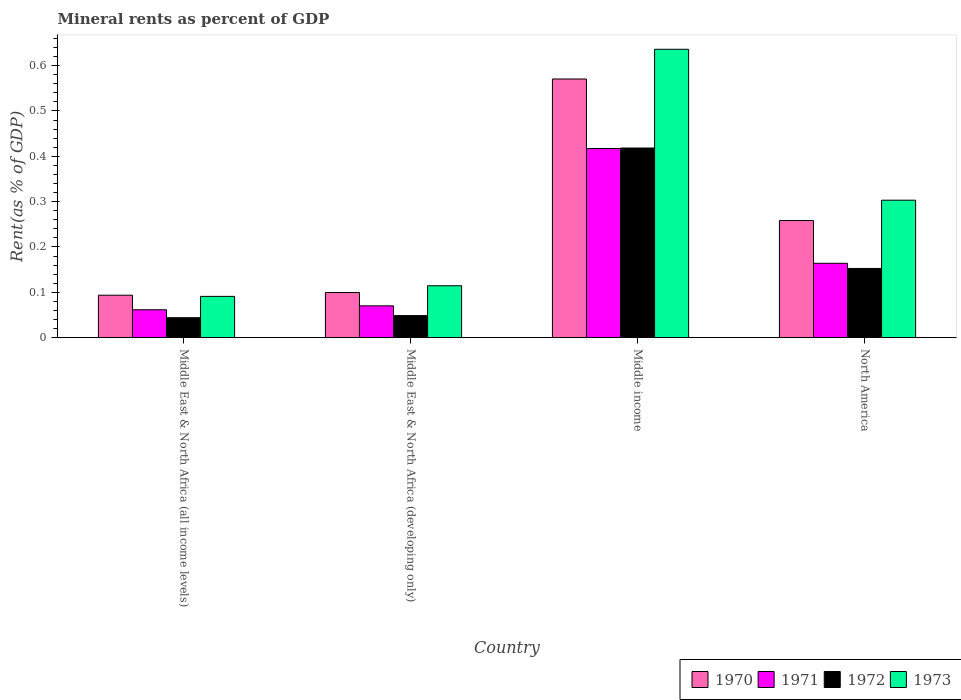How many different coloured bars are there?
Give a very brief answer. 4. Are the number of bars per tick equal to the number of legend labels?
Provide a succinct answer. Yes. Are the number of bars on each tick of the X-axis equal?
Provide a short and direct response. Yes. How many bars are there on the 4th tick from the right?
Keep it short and to the point. 4. What is the mineral rent in 1971 in Middle income?
Provide a short and direct response. 0.42. Across all countries, what is the maximum mineral rent in 1973?
Your answer should be very brief. 0.64. Across all countries, what is the minimum mineral rent in 1970?
Make the answer very short. 0.09. In which country was the mineral rent in 1971 minimum?
Offer a terse response. Middle East & North Africa (all income levels). What is the total mineral rent in 1971 in the graph?
Provide a short and direct response. 0.71. What is the difference between the mineral rent in 1970 in Middle East & North Africa (all income levels) and that in Middle income?
Your response must be concise. -0.48. What is the difference between the mineral rent in 1973 in Middle East & North Africa (all income levels) and the mineral rent in 1972 in Middle income?
Your answer should be very brief. -0.33. What is the average mineral rent in 1972 per country?
Give a very brief answer. 0.17. What is the difference between the mineral rent of/in 1973 and mineral rent of/in 1971 in Middle income?
Make the answer very short. 0.22. In how many countries, is the mineral rent in 1971 greater than 0.04 %?
Offer a terse response. 4. What is the ratio of the mineral rent in 1973 in Middle income to that in North America?
Make the answer very short. 2.1. Is the mineral rent in 1972 in Middle East & North Africa (developing only) less than that in North America?
Keep it short and to the point. Yes. What is the difference between the highest and the second highest mineral rent in 1971?
Provide a succinct answer. 0.25. What is the difference between the highest and the lowest mineral rent in 1971?
Give a very brief answer. 0.36. Is the sum of the mineral rent in 1973 in Middle East & North Africa (developing only) and Middle income greater than the maximum mineral rent in 1972 across all countries?
Provide a short and direct response. Yes. What does the 2nd bar from the left in Middle income represents?
Make the answer very short. 1971. What does the 3rd bar from the right in Middle income represents?
Offer a very short reply. 1971. Is it the case that in every country, the sum of the mineral rent in 1973 and mineral rent in 1972 is greater than the mineral rent in 1971?
Offer a terse response. Yes. Are all the bars in the graph horizontal?
Make the answer very short. No. What is the difference between two consecutive major ticks on the Y-axis?
Make the answer very short. 0.1. Are the values on the major ticks of Y-axis written in scientific E-notation?
Provide a succinct answer. No. Does the graph contain any zero values?
Offer a very short reply. No. How are the legend labels stacked?
Your response must be concise. Horizontal. What is the title of the graph?
Your response must be concise. Mineral rents as percent of GDP. What is the label or title of the Y-axis?
Your answer should be very brief. Rent(as % of GDP). What is the Rent(as % of GDP) in 1970 in Middle East & North Africa (all income levels)?
Your answer should be very brief. 0.09. What is the Rent(as % of GDP) in 1971 in Middle East & North Africa (all income levels)?
Give a very brief answer. 0.06. What is the Rent(as % of GDP) of 1972 in Middle East & North Africa (all income levels)?
Your answer should be compact. 0.04. What is the Rent(as % of GDP) of 1973 in Middle East & North Africa (all income levels)?
Offer a terse response. 0.09. What is the Rent(as % of GDP) of 1970 in Middle East & North Africa (developing only)?
Offer a terse response. 0.1. What is the Rent(as % of GDP) in 1971 in Middle East & North Africa (developing only)?
Offer a very short reply. 0.07. What is the Rent(as % of GDP) in 1972 in Middle East & North Africa (developing only)?
Ensure brevity in your answer.  0.05. What is the Rent(as % of GDP) of 1973 in Middle East & North Africa (developing only)?
Offer a terse response. 0.11. What is the Rent(as % of GDP) in 1970 in Middle income?
Make the answer very short. 0.57. What is the Rent(as % of GDP) in 1971 in Middle income?
Make the answer very short. 0.42. What is the Rent(as % of GDP) of 1972 in Middle income?
Keep it short and to the point. 0.42. What is the Rent(as % of GDP) in 1973 in Middle income?
Offer a very short reply. 0.64. What is the Rent(as % of GDP) in 1970 in North America?
Make the answer very short. 0.26. What is the Rent(as % of GDP) in 1971 in North America?
Provide a short and direct response. 0.16. What is the Rent(as % of GDP) in 1972 in North America?
Ensure brevity in your answer.  0.15. What is the Rent(as % of GDP) in 1973 in North America?
Your response must be concise. 0.3. Across all countries, what is the maximum Rent(as % of GDP) in 1970?
Give a very brief answer. 0.57. Across all countries, what is the maximum Rent(as % of GDP) of 1971?
Keep it short and to the point. 0.42. Across all countries, what is the maximum Rent(as % of GDP) in 1972?
Offer a terse response. 0.42. Across all countries, what is the maximum Rent(as % of GDP) of 1973?
Make the answer very short. 0.64. Across all countries, what is the minimum Rent(as % of GDP) in 1970?
Provide a succinct answer. 0.09. Across all countries, what is the minimum Rent(as % of GDP) in 1971?
Make the answer very short. 0.06. Across all countries, what is the minimum Rent(as % of GDP) in 1972?
Offer a very short reply. 0.04. Across all countries, what is the minimum Rent(as % of GDP) in 1973?
Offer a very short reply. 0.09. What is the total Rent(as % of GDP) in 1970 in the graph?
Provide a short and direct response. 1.02. What is the total Rent(as % of GDP) of 1971 in the graph?
Provide a succinct answer. 0.71. What is the total Rent(as % of GDP) in 1972 in the graph?
Offer a very short reply. 0.66. What is the total Rent(as % of GDP) of 1973 in the graph?
Keep it short and to the point. 1.14. What is the difference between the Rent(as % of GDP) of 1970 in Middle East & North Africa (all income levels) and that in Middle East & North Africa (developing only)?
Make the answer very short. -0.01. What is the difference between the Rent(as % of GDP) of 1971 in Middle East & North Africa (all income levels) and that in Middle East & North Africa (developing only)?
Ensure brevity in your answer.  -0.01. What is the difference between the Rent(as % of GDP) in 1972 in Middle East & North Africa (all income levels) and that in Middle East & North Africa (developing only)?
Provide a short and direct response. -0. What is the difference between the Rent(as % of GDP) in 1973 in Middle East & North Africa (all income levels) and that in Middle East & North Africa (developing only)?
Your answer should be very brief. -0.02. What is the difference between the Rent(as % of GDP) of 1970 in Middle East & North Africa (all income levels) and that in Middle income?
Give a very brief answer. -0.48. What is the difference between the Rent(as % of GDP) of 1971 in Middle East & North Africa (all income levels) and that in Middle income?
Your answer should be compact. -0.36. What is the difference between the Rent(as % of GDP) of 1972 in Middle East & North Africa (all income levels) and that in Middle income?
Give a very brief answer. -0.37. What is the difference between the Rent(as % of GDP) in 1973 in Middle East & North Africa (all income levels) and that in Middle income?
Offer a very short reply. -0.55. What is the difference between the Rent(as % of GDP) in 1970 in Middle East & North Africa (all income levels) and that in North America?
Ensure brevity in your answer.  -0.16. What is the difference between the Rent(as % of GDP) in 1971 in Middle East & North Africa (all income levels) and that in North America?
Provide a short and direct response. -0.1. What is the difference between the Rent(as % of GDP) of 1972 in Middle East & North Africa (all income levels) and that in North America?
Your answer should be very brief. -0.11. What is the difference between the Rent(as % of GDP) of 1973 in Middle East & North Africa (all income levels) and that in North America?
Ensure brevity in your answer.  -0.21. What is the difference between the Rent(as % of GDP) of 1970 in Middle East & North Africa (developing only) and that in Middle income?
Provide a short and direct response. -0.47. What is the difference between the Rent(as % of GDP) of 1971 in Middle East & North Africa (developing only) and that in Middle income?
Ensure brevity in your answer.  -0.35. What is the difference between the Rent(as % of GDP) of 1972 in Middle East & North Africa (developing only) and that in Middle income?
Give a very brief answer. -0.37. What is the difference between the Rent(as % of GDP) in 1973 in Middle East & North Africa (developing only) and that in Middle income?
Provide a short and direct response. -0.52. What is the difference between the Rent(as % of GDP) in 1970 in Middle East & North Africa (developing only) and that in North America?
Make the answer very short. -0.16. What is the difference between the Rent(as % of GDP) of 1971 in Middle East & North Africa (developing only) and that in North America?
Offer a very short reply. -0.09. What is the difference between the Rent(as % of GDP) of 1972 in Middle East & North Africa (developing only) and that in North America?
Your answer should be compact. -0.1. What is the difference between the Rent(as % of GDP) of 1973 in Middle East & North Africa (developing only) and that in North America?
Offer a very short reply. -0.19. What is the difference between the Rent(as % of GDP) in 1970 in Middle income and that in North America?
Make the answer very short. 0.31. What is the difference between the Rent(as % of GDP) in 1971 in Middle income and that in North America?
Your response must be concise. 0.25. What is the difference between the Rent(as % of GDP) of 1972 in Middle income and that in North America?
Your response must be concise. 0.27. What is the difference between the Rent(as % of GDP) in 1973 in Middle income and that in North America?
Offer a terse response. 0.33. What is the difference between the Rent(as % of GDP) of 1970 in Middle East & North Africa (all income levels) and the Rent(as % of GDP) of 1971 in Middle East & North Africa (developing only)?
Ensure brevity in your answer.  0.02. What is the difference between the Rent(as % of GDP) of 1970 in Middle East & North Africa (all income levels) and the Rent(as % of GDP) of 1972 in Middle East & North Africa (developing only)?
Give a very brief answer. 0.04. What is the difference between the Rent(as % of GDP) in 1970 in Middle East & North Africa (all income levels) and the Rent(as % of GDP) in 1973 in Middle East & North Africa (developing only)?
Your answer should be very brief. -0.02. What is the difference between the Rent(as % of GDP) of 1971 in Middle East & North Africa (all income levels) and the Rent(as % of GDP) of 1972 in Middle East & North Africa (developing only)?
Ensure brevity in your answer.  0.01. What is the difference between the Rent(as % of GDP) of 1971 in Middle East & North Africa (all income levels) and the Rent(as % of GDP) of 1973 in Middle East & North Africa (developing only)?
Ensure brevity in your answer.  -0.05. What is the difference between the Rent(as % of GDP) in 1972 in Middle East & North Africa (all income levels) and the Rent(as % of GDP) in 1973 in Middle East & North Africa (developing only)?
Give a very brief answer. -0.07. What is the difference between the Rent(as % of GDP) in 1970 in Middle East & North Africa (all income levels) and the Rent(as % of GDP) in 1971 in Middle income?
Your answer should be compact. -0.32. What is the difference between the Rent(as % of GDP) of 1970 in Middle East & North Africa (all income levels) and the Rent(as % of GDP) of 1972 in Middle income?
Offer a terse response. -0.32. What is the difference between the Rent(as % of GDP) of 1970 in Middle East & North Africa (all income levels) and the Rent(as % of GDP) of 1973 in Middle income?
Ensure brevity in your answer.  -0.54. What is the difference between the Rent(as % of GDP) in 1971 in Middle East & North Africa (all income levels) and the Rent(as % of GDP) in 1972 in Middle income?
Provide a short and direct response. -0.36. What is the difference between the Rent(as % of GDP) of 1971 in Middle East & North Africa (all income levels) and the Rent(as % of GDP) of 1973 in Middle income?
Provide a short and direct response. -0.57. What is the difference between the Rent(as % of GDP) of 1972 in Middle East & North Africa (all income levels) and the Rent(as % of GDP) of 1973 in Middle income?
Make the answer very short. -0.59. What is the difference between the Rent(as % of GDP) in 1970 in Middle East & North Africa (all income levels) and the Rent(as % of GDP) in 1971 in North America?
Your response must be concise. -0.07. What is the difference between the Rent(as % of GDP) of 1970 in Middle East & North Africa (all income levels) and the Rent(as % of GDP) of 1972 in North America?
Your response must be concise. -0.06. What is the difference between the Rent(as % of GDP) of 1970 in Middle East & North Africa (all income levels) and the Rent(as % of GDP) of 1973 in North America?
Ensure brevity in your answer.  -0.21. What is the difference between the Rent(as % of GDP) in 1971 in Middle East & North Africa (all income levels) and the Rent(as % of GDP) in 1972 in North America?
Give a very brief answer. -0.09. What is the difference between the Rent(as % of GDP) in 1971 in Middle East & North Africa (all income levels) and the Rent(as % of GDP) in 1973 in North America?
Give a very brief answer. -0.24. What is the difference between the Rent(as % of GDP) of 1972 in Middle East & North Africa (all income levels) and the Rent(as % of GDP) of 1973 in North America?
Your answer should be very brief. -0.26. What is the difference between the Rent(as % of GDP) of 1970 in Middle East & North Africa (developing only) and the Rent(as % of GDP) of 1971 in Middle income?
Your answer should be very brief. -0.32. What is the difference between the Rent(as % of GDP) in 1970 in Middle East & North Africa (developing only) and the Rent(as % of GDP) in 1972 in Middle income?
Give a very brief answer. -0.32. What is the difference between the Rent(as % of GDP) of 1970 in Middle East & North Africa (developing only) and the Rent(as % of GDP) of 1973 in Middle income?
Your answer should be compact. -0.54. What is the difference between the Rent(as % of GDP) of 1971 in Middle East & North Africa (developing only) and the Rent(as % of GDP) of 1972 in Middle income?
Give a very brief answer. -0.35. What is the difference between the Rent(as % of GDP) in 1971 in Middle East & North Africa (developing only) and the Rent(as % of GDP) in 1973 in Middle income?
Offer a terse response. -0.57. What is the difference between the Rent(as % of GDP) in 1972 in Middle East & North Africa (developing only) and the Rent(as % of GDP) in 1973 in Middle income?
Offer a very short reply. -0.59. What is the difference between the Rent(as % of GDP) in 1970 in Middle East & North Africa (developing only) and the Rent(as % of GDP) in 1971 in North America?
Provide a succinct answer. -0.06. What is the difference between the Rent(as % of GDP) in 1970 in Middle East & North Africa (developing only) and the Rent(as % of GDP) in 1972 in North America?
Provide a short and direct response. -0.05. What is the difference between the Rent(as % of GDP) in 1970 in Middle East & North Africa (developing only) and the Rent(as % of GDP) in 1973 in North America?
Keep it short and to the point. -0.2. What is the difference between the Rent(as % of GDP) of 1971 in Middle East & North Africa (developing only) and the Rent(as % of GDP) of 1972 in North America?
Your answer should be compact. -0.08. What is the difference between the Rent(as % of GDP) in 1971 in Middle East & North Africa (developing only) and the Rent(as % of GDP) in 1973 in North America?
Provide a succinct answer. -0.23. What is the difference between the Rent(as % of GDP) of 1972 in Middle East & North Africa (developing only) and the Rent(as % of GDP) of 1973 in North America?
Provide a short and direct response. -0.25. What is the difference between the Rent(as % of GDP) in 1970 in Middle income and the Rent(as % of GDP) in 1971 in North America?
Provide a succinct answer. 0.41. What is the difference between the Rent(as % of GDP) of 1970 in Middle income and the Rent(as % of GDP) of 1972 in North America?
Make the answer very short. 0.42. What is the difference between the Rent(as % of GDP) of 1970 in Middle income and the Rent(as % of GDP) of 1973 in North America?
Your response must be concise. 0.27. What is the difference between the Rent(as % of GDP) of 1971 in Middle income and the Rent(as % of GDP) of 1972 in North America?
Offer a very short reply. 0.26. What is the difference between the Rent(as % of GDP) of 1971 in Middle income and the Rent(as % of GDP) of 1973 in North America?
Ensure brevity in your answer.  0.11. What is the difference between the Rent(as % of GDP) in 1972 in Middle income and the Rent(as % of GDP) in 1973 in North America?
Offer a terse response. 0.12. What is the average Rent(as % of GDP) in 1970 per country?
Your answer should be compact. 0.26. What is the average Rent(as % of GDP) in 1971 per country?
Make the answer very short. 0.18. What is the average Rent(as % of GDP) in 1972 per country?
Keep it short and to the point. 0.17. What is the average Rent(as % of GDP) of 1973 per country?
Offer a terse response. 0.29. What is the difference between the Rent(as % of GDP) of 1970 and Rent(as % of GDP) of 1971 in Middle East & North Africa (all income levels)?
Provide a succinct answer. 0.03. What is the difference between the Rent(as % of GDP) in 1970 and Rent(as % of GDP) in 1972 in Middle East & North Africa (all income levels)?
Offer a terse response. 0.05. What is the difference between the Rent(as % of GDP) in 1970 and Rent(as % of GDP) in 1973 in Middle East & North Africa (all income levels)?
Provide a succinct answer. 0. What is the difference between the Rent(as % of GDP) in 1971 and Rent(as % of GDP) in 1972 in Middle East & North Africa (all income levels)?
Your response must be concise. 0.02. What is the difference between the Rent(as % of GDP) of 1971 and Rent(as % of GDP) of 1973 in Middle East & North Africa (all income levels)?
Provide a short and direct response. -0.03. What is the difference between the Rent(as % of GDP) of 1972 and Rent(as % of GDP) of 1973 in Middle East & North Africa (all income levels)?
Make the answer very short. -0.05. What is the difference between the Rent(as % of GDP) in 1970 and Rent(as % of GDP) in 1971 in Middle East & North Africa (developing only)?
Give a very brief answer. 0.03. What is the difference between the Rent(as % of GDP) of 1970 and Rent(as % of GDP) of 1972 in Middle East & North Africa (developing only)?
Keep it short and to the point. 0.05. What is the difference between the Rent(as % of GDP) in 1970 and Rent(as % of GDP) in 1973 in Middle East & North Africa (developing only)?
Ensure brevity in your answer.  -0.01. What is the difference between the Rent(as % of GDP) of 1971 and Rent(as % of GDP) of 1972 in Middle East & North Africa (developing only)?
Offer a very short reply. 0.02. What is the difference between the Rent(as % of GDP) in 1971 and Rent(as % of GDP) in 1973 in Middle East & North Africa (developing only)?
Offer a very short reply. -0.04. What is the difference between the Rent(as % of GDP) of 1972 and Rent(as % of GDP) of 1973 in Middle East & North Africa (developing only)?
Provide a short and direct response. -0.07. What is the difference between the Rent(as % of GDP) of 1970 and Rent(as % of GDP) of 1971 in Middle income?
Give a very brief answer. 0.15. What is the difference between the Rent(as % of GDP) in 1970 and Rent(as % of GDP) in 1972 in Middle income?
Keep it short and to the point. 0.15. What is the difference between the Rent(as % of GDP) in 1970 and Rent(as % of GDP) in 1973 in Middle income?
Provide a succinct answer. -0.07. What is the difference between the Rent(as % of GDP) in 1971 and Rent(as % of GDP) in 1972 in Middle income?
Offer a very short reply. -0. What is the difference between the Rent(as % of GDP) in 1971 and Rent(as % of GDP) in 1973 in Middle income?
Ensure brevity in your answer.  -0.22. What is the difference between the Rent(as % of GDP) in 1972 and Rent(as % of GDP) in 1973 in Middle income?
Your answer should be compact. -0.22. What is the difference between the Rent(as % of GDP) in 1970 and Rent(as % of GDP) in 1971 in North America?
Give a very brief answer. 0.09. What is the difference between the Rent(as % of GDP) in 1970 and Rent(as % of GDP) in 1972 in North America?
Make the answer very short. 0.11. What is the difference between the Rent(as % of GDP) in 1970 and Rent(as % of GDP) in 1973 in North America?
Keep it short and to the point. -0.04. What is the difference between the Rent(as % of GDP) of 1971 and Rent(as % of GDP) of 1972 in North America?
Make the answer very short. 0.01. What is the difference between the Rent(as % of GDP) of 1971 and Rent(as % of GDP) of 1973 in North America?
Provide a succinct answer. -0.14. What is the difference between the Rent(as % of GDP) in 1972 and Rent(as % of GDP) in 1973 in North America?
Keep it short and to the point. -0.15. What is the ratio of the Rent(as % of GDP) of 1970 in Middle East & North Africa (all income levels) to that in Middle East & North Africa (developing only)?
Keep it short and to the point. 0.94. What is the ratio of the Rent(as % of GDP) in 1971 in Middle East & North Africa (all income levels) to that in Middle East & North Africa (developing only)?
Ensure brevity in your answer.  0.88. What is the ratio of the Rent(as % of GDP) in 1972 in Middle East & North Africa (all income levels) to that in Middle East & North Africa (developing only)?
Make the answer very short. 0.9. What is the ratio of the Rent(as % of GDP) in 1973 in Middle East & North Africa (all income levels) to that in Middle East & North Africa (developing only)?
Provide a succinct answer. 0.8. What is the ratio of the Rent(as % of GDP) of 1970 in Middle East & North Africa (all income levels) to that in Middle income?
Your response must be concise. 0.16. What is the ratio of the Rent(as % of GDP) in 1971 in Middle East & North Africa (all income levels) to that in Middle income?
Provide a succinct answer. 0.15. What is the ratio of the Rent(as % of GDP) in 1972 in Middle East & North Africa (all income levels) to that in Middle income?
Your answer should be very brief. 0.11. What is the ratio of the Rent(as % of GDP) in 1973 in Middle East & North Africa (all income levels) to that in Middle income?
Offer a terse response. 0.14. What is the ratio of the Rent(as % of GDP) of 1970 in Middle East & North Africa (all income levels) to that in North America?
Your answer should be compact. 0.36. What is the ratio of the Rent(as % of GDP) of 1972 in Middle East & North Africa (all income levels) to that in North America?
Give a very brief answer. 0.29. What is the ratio of the Rent(as % of GDP) in 1973 in Middle East & North Africa (all income levels) to that in North America?
Your response must be concise. 0.3. What is the ratio of the Rent(as % of GDP) of 1970 in Middle East & North Africa (developing only) to that in Middle income?
Keep it short and to the point. 0.17. What is the ratio of the Rent(as % of GDP) in 1971 in Middle East & North Africa (developing only) to that in Middle income?
Provide a succinct answer. 0.17. What is the ratio of the Rent(as % of GDP) in 1972 in Middle East & North Africa (developing only) to that in Middle income?
Offer a very short reply. 0.12. What is the ratio of the Rent(as % of GDP) of 1973 in Middle East & North Africa (developing only) to that in Middle income?
Offer a very short reply. 0.18. What is the ratio of the Rent(as % of GDP) in 1970 in Middle East & North Africa (developing only) to that in North America?
Your response must be concise. 0.39. What is the ratio of the Rent(as % of GDP) of 1971 in Middle East & North Africa (developing only) to that in North America?
Give a very brief answer. 0.43. What is the ratio of the Rent(as % of GDP) in 1972 in Middle East & North Africa (developing only) to that in North America?
Provide a short and direct response. 0.32. What is the ratio of the Rent(as % of GDP) in 1973 in Middle East & North Africa (developing only) to that in North America?
Your response must be concise. 0.38. What is the ratio of the Rent(as % of GDP) in 1970 in Middle income to that in North America?
Ensure brevity in your answer.  2.21. What is the ratio of the Rent(as % of GDP) in 1971 in Middle income to that in North America?
Keep it short and to the point. 2.54. What is the ratio of the Rent(as % of GDP) of 1972 in Middle income to that in North America?
Your answer should be compact. 2.74. What is the ratio of the Rent(as % of GDP) of 1973 in Middle income to that in North America?
Your response must be concise. 2.1. What is the difference between the highest and the second highest Rent(as % of GDP) of 1970?
Keep it short and to the point. 0.31. What is the difference between the highest and the second highest Rent(as % of GDP) of 1971?
Offer a terse response. 0.25. What is the difference between the highest and the second highest Rent(as % of GDP) in 1972?
Give a very brief answer. 0.27. What is the difference between the highest and the second highest Rent(as % of GDP) of 1973?
Ensure brevity in your answer.  0.33. What is the difference between the highest and the lowest Rent(as % of GDP) of 1970?
Make the answer very short. 0.48. What is the difference between the highest and the lowest Rent(as % of GDP) of 1971?
Your answer should be compact. 0.36. What is the difference between the highest and the lowest Rent(as % of GDP) in 1972?
Make the answer very short. 0.37. What is the difference between the highest and the lowest Rent(as % of GDP) in 1973?
Keep it short and to the point. 0.55. 